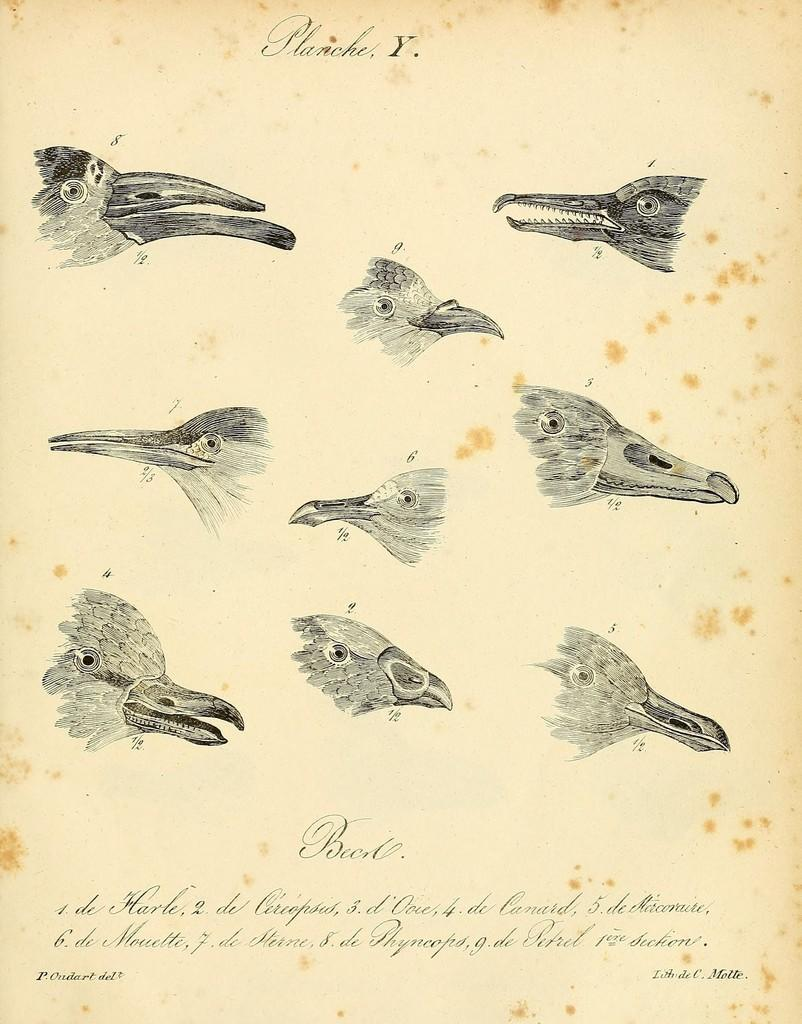What objects are featured in the image? There are bird beaks in the image. Where are the bird beaks located? The bird beaks are on a paper. What type of power source is connected to the bird beaks in the image? There is no power source or any electrical components connected to the bird beaks in the image. 